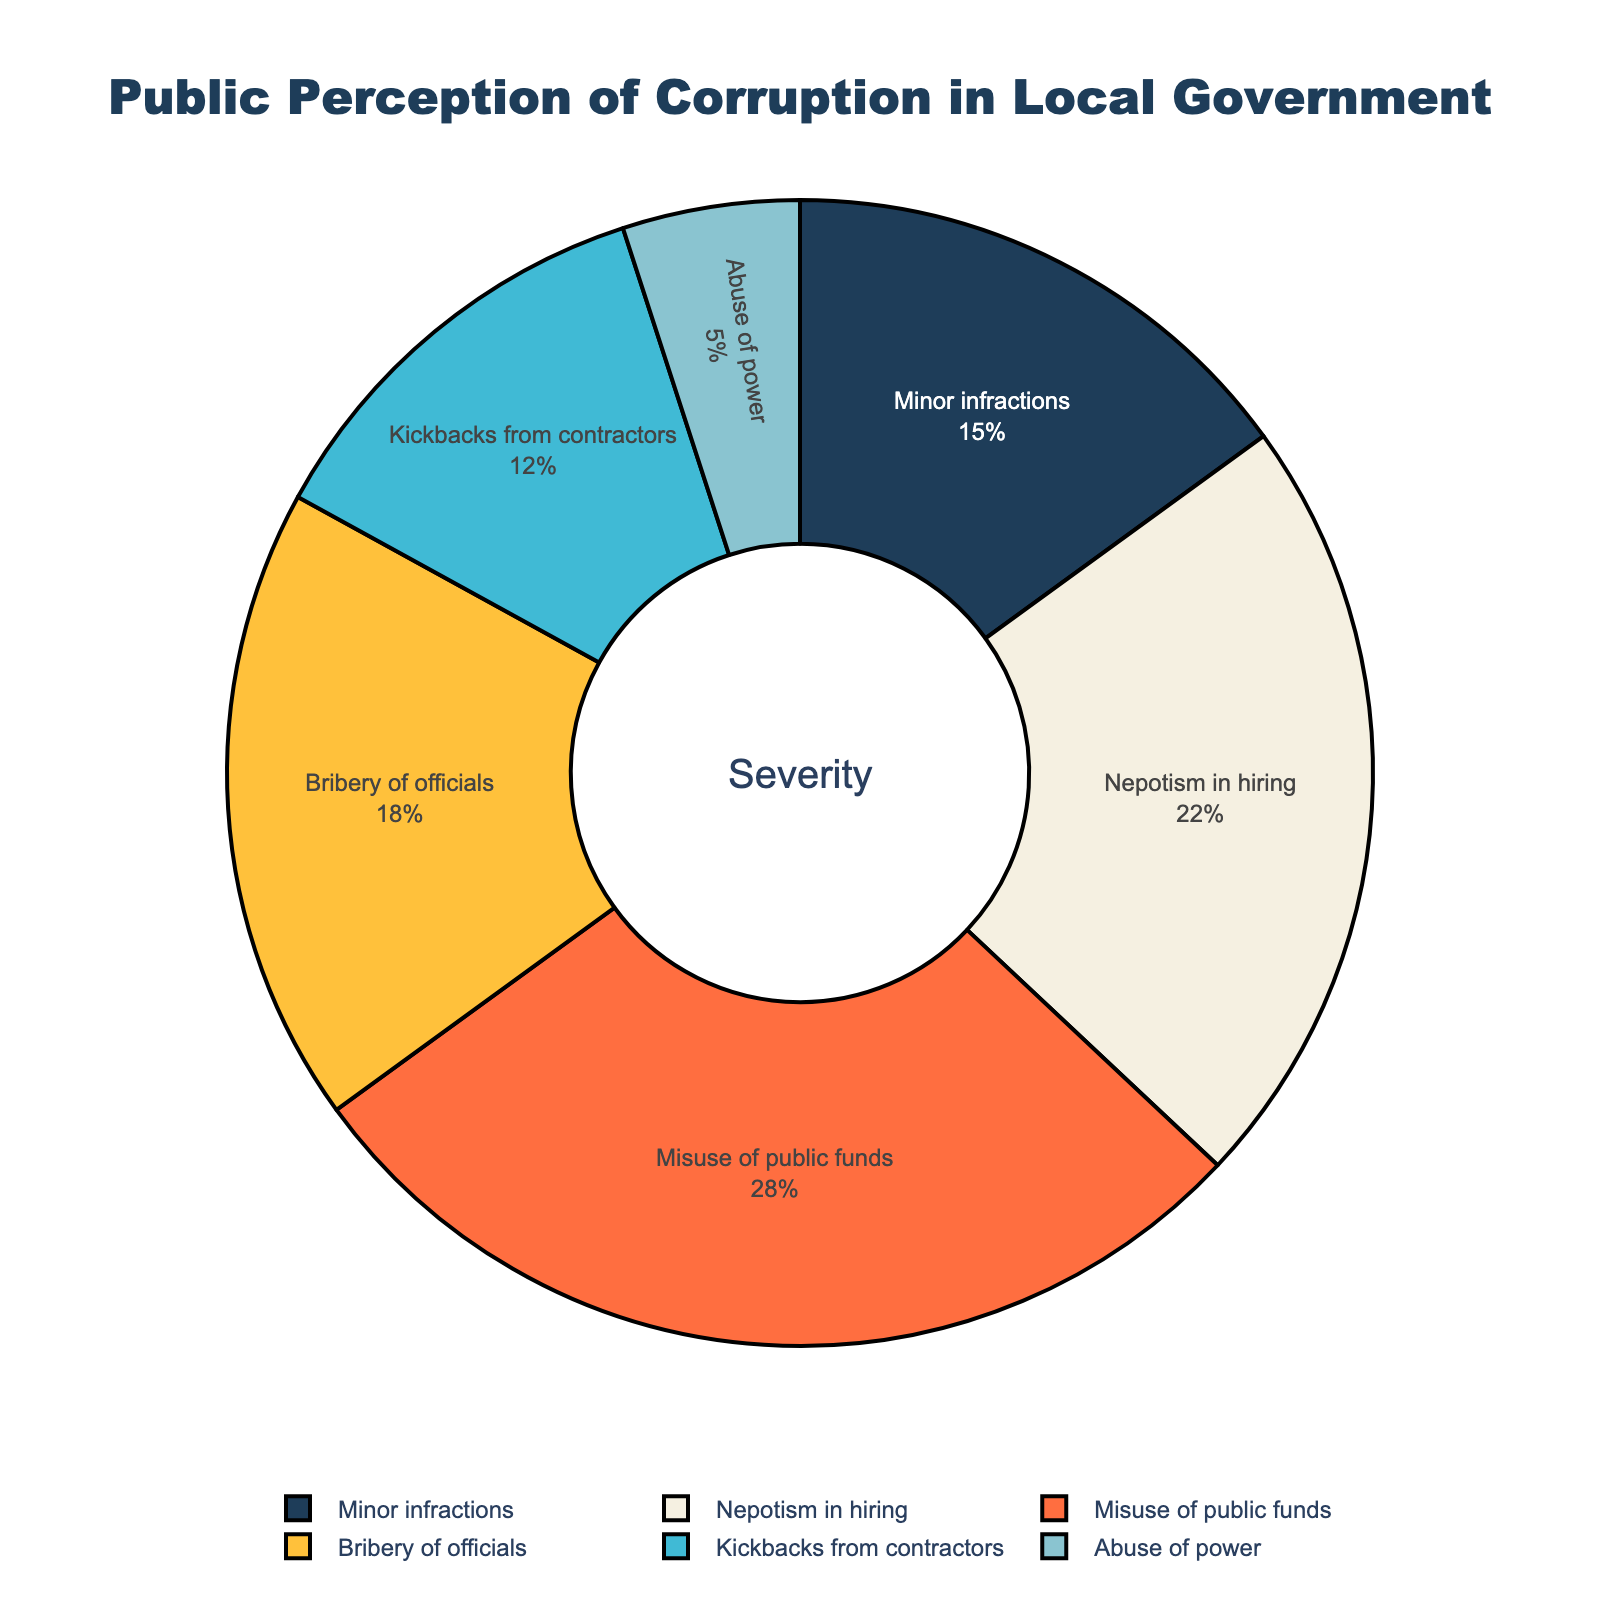What percentage of people perceive bribery of officials as a problem? The pie chart shows different severities of perceived corruption along with their respective percentages. Looking at the section labeled 'Bribery of officials', it shows it accounts for 18% of the responses.
Answer: 18% Which category has the highest perceived severity of corruption? The pie chart displays several categories and their respective percentages. The category labeled 'Misuse of public funds' has the largest segment at 28%.
Answer: Misuse of public funds What is the combined percentage of those who perceive nepotism in hiring and misuse of public funds as significant problems? The pie chart shows the percentage of people who perceive each type of corruption. Nepotism in hiring is 22% and misuse of public funds is 28%. Adding these gives 22% + 28% = 50%.
Answer: 50% Which category has a higher perceived severity, kickbacks from contractors or abuse of power? The pie chart shows the perceived percentage for each category. Kickbacks from contractors have 12%, while abuse of power has 5%. Since 12% is greater than 5%, kickbacks from contractors are perceived as a more severe issue.
Answer: Kickbacks from contractors What is the percentage of minor infractions perceived in local government corruption? The pie chart shows a section labeled 'Minor infractions', which constitutes 15% of the responses.
Answer: 15% How much greater is the perception of misuse of public funds compared to kickbacks from contractors? The misuse of public funds is perceived by 28%, while kickbacks from contractors are perceived by 12%. The difference is 28% - 12% = 16%.
Answer: 16% What is the total percentage of people who perceive either minor infractions or abuse of power as issues in local government? The pie chart shows 15% for minor infractions and 5% for abuse of power. Adding these gives 15% + 5% = 20%.
Answer: 20% Looking at the overall distribution, which category is perceived least severely? The pie chart has several categories, with 'Abuse of power' having the smallest segment at 5%.
Answer: Abuse of power 